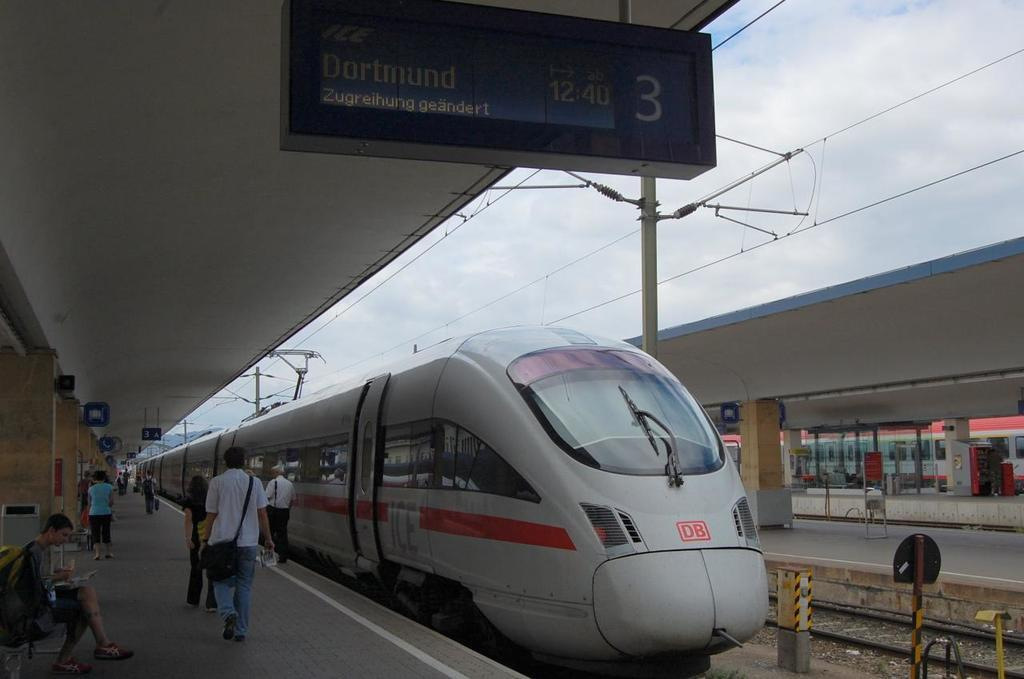What is the main subject of the image? The main subject of the image is a train on a railway track. What else can be seen in the image besides the train? There are wires visible in the image, as well as people on the platform and a person sitting on a bench. What are the boards used for in the image? The boards present in the image could be used for signage or information purposes. What type of stew is being prepared by the person sitting on the bench in the image? There is no person preparing stew in the image; the person sitting on the bench is not engaged in any cooking activity. 